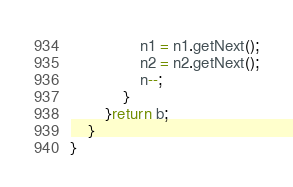<code> <loc_0><loc_0><loc_500><loc_500><_Java_>                n1 = n1.getNext();
                n2 = n2.getNext();
                n--;
            }
        }return b;
    }
}
</code> 